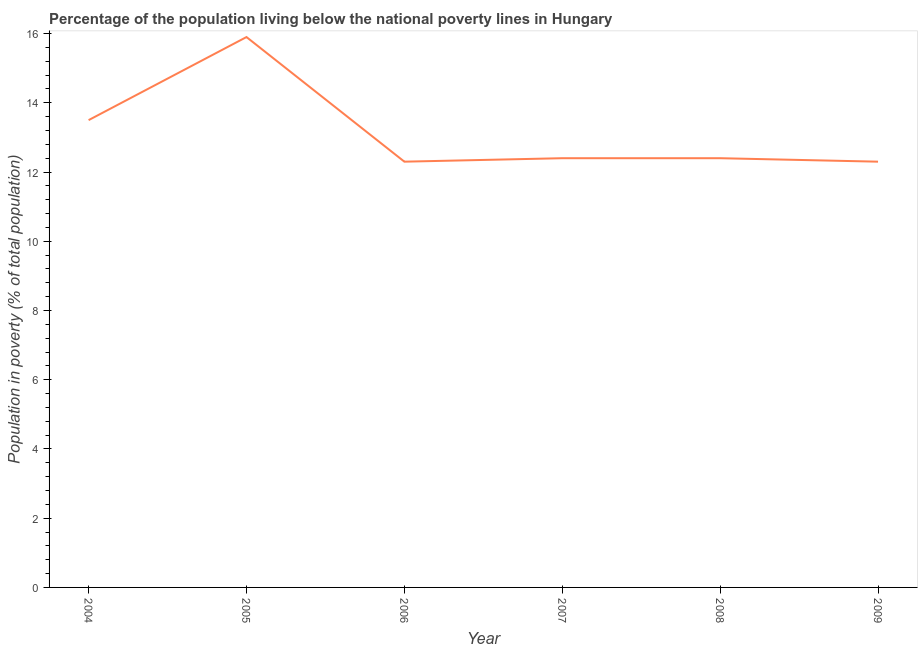In which year was the percentage of population living below poverty line maximum?
Make the answer very short. 2005. In which year was the percentage of population living below poverty line minimum?
Provide a short and direct response. 2006. What is the sum of the percentage of population living below poverty line?
Give a very brief answer. 78.8. What is the average percentage of population living below poverty line per year?
Offer a very short reply. 13.13. Do a majority of the years between 2006 and 2008 (inclusive) have percentage of population living below poverty line greater than 14.8 %?
Offer a terse response. No. What is the ratio of the percentage of population living below poverty line in 2006 to that in 2007?
Provide a short and direct response. 0.99. Is the percentage of population living below poverty line in 2008 less than that in 2009?
Your response must be concise. No. Is the difference between the percentage of population living below poverty line in 2007 and 2009 greater than the difference between any two years?
Your answer should be compact. No. What is the difference between the highest and the second highest percentage of population living below poverty line?
Your answer should be very brief. 2.4. Is the sum of the percentage of population living below poverty line in 2007 and 2008 greater than the maximum percentage of population living below poverty line across all years?
Offer a very short reply. Yes. What is the difference between the highest and the lowest percentage of population living below poverty line?
Provide a short and direct response. 3.6. In how many years, is the percentage of population living below poverty line greater than the average percentage of population living below poverty line taken over all years?
Your answer should be very brief. 2. Does the percentage of population living below poverty line monotonically increase over the years?
Make the answer very short. No. How many lines are there?
Provide a succinct answer. 1. How many years are there in the graph?
Your answer should be very brief. 6. What is the difference between two consecutive major ticks on the Y-axis?
Your response must be concise. 2. Does the graph contain any zero values?
Offer a terse response. No. What is the title of the graph?
Provide a short and direct response. Percentage of the population living below the national poverty lines in Hungary. What is the label or title of the X-axis?
Make the answer very short. Year. What is the label or title of the Y-axis?
Offer a very short reply. Population in poverty (% of total population). What is the Population in poverty (% of total population) in 2007?
Your answer should be compact. 12.4. What is the Population in poverty (% of total population) in 2009?
Provide a short and direct response. 12.3. What is the difference between the Population in poverty (% of total population) in 2004 and 2007?
Provide a short and direct response. 1.1. What is the difference between the Population in poverty (% of total population) in 2005 and 2006?
Ensure brevity in your answer.  3.6. What is the difference between the Population in poverty (% of total population) in 2005 and 2007?
Keep it short and to the point. 3.5. What is the difference between the Population in poverty (% of total population) in 2006 and 2007?
Make the answer very short. -0.1. What is the difference between the Population in poverty (% of total population) in 2006 and 2009?
Make the answer very short. 0. What is the difference between the Population in poverty (% of total population) in 2007 and 2008?
Your answer should be very brief. 0. What is the difference between the Population in poverty (% of total population) in 2007 and 2009?
Give a very brief answer. 0.1. What is the ratio of the Population in poverty (% of total population) in 2004 to that in 2005?
Your response must be concise. 0.85. What is the ratio of the Population in poverty (% of total population) in 2004 to that in 2006?
Your answer should be very brief. 1.1. What is the ratio of the Population in poverty (% of total population) in 2004 to that in 2007?
Ensure brevity in your answer.  1.09. What is the ratio of the Population in poverty (% of total population) in 2004 to that in 2008?
Keep it short and to the point. 1.09. What is the ratio of the Population in poverty (% of total population) in 2004 to that in 2009?
Your response must be concise. 1.1. What is the ratio of the Population in poverty (% of total population) in 2005 to that in 2006?
Give a very brief answer. 1.29. What is the ratio of the Population in poverty (% of total population) in 2005 to that in 2007?
Your answer should be very brief. 1.28. What is the ratio of the Population in poverty (% of total population) in 2005 to that in 2008?
Make the answer very short. 1.28. What is the ratio of the Population in poverty (% of total population) in 2005 to that in 2009?
Offer a very short reply. 1.29. What is the ratio of the Population in poverty (% of total population) in 2006 to that in 2007?
Your response must be concise. 0.99. What is the ratio of the Population in poverty (% of total population) in 2007 to that in 2009?
Offer a terse response. 1.01. What is the ratio of the Population in poverty (% of total population) in 2008 to that in 2009?
Make the answer very short. 1.01. 